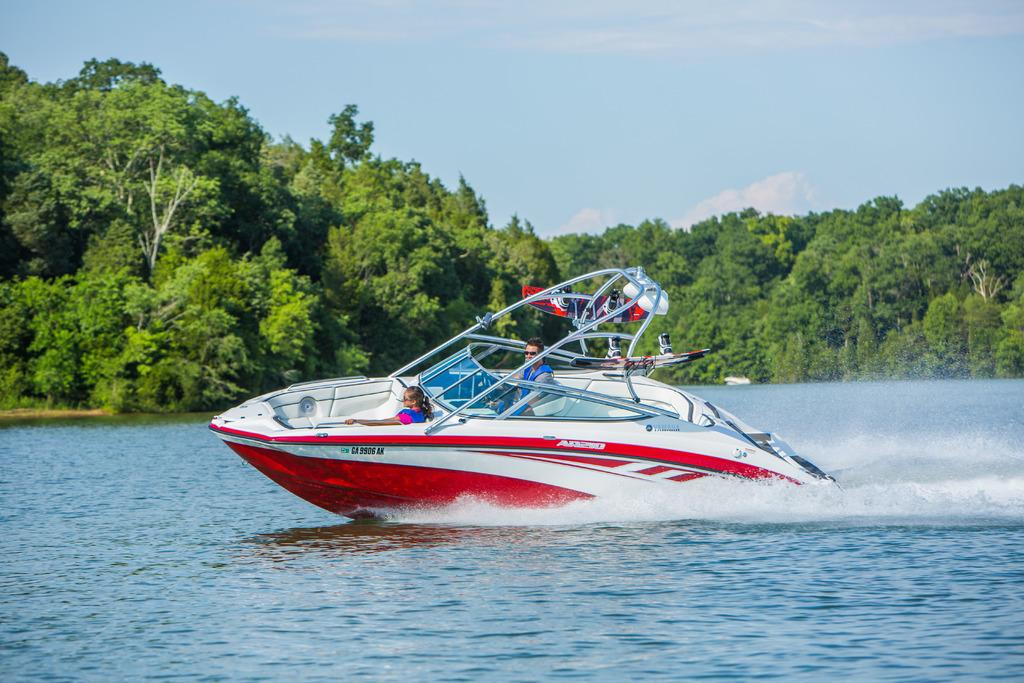How many people are in the image? There are two persons in the image. What are the two persons doing in the image? The two persons are in a boat. Can you describe the color combination of the boat? The boat is in a white and red color combination. Where is the boat located in the image? The boat is on the water. What can be seen in the background of the image? There are trees and clouds in the sky in the background of the image. What type of umbrella is being used by the cattle in the image? There are no cattle or umbrellas present in the image. What subject is the person on the left teaching to the person on the right in the image? There is no indication of teaching or any specific subject being taught in the image. 